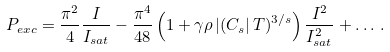Convert formula to latex. <formula><loc_0><loc_0><loc_500><loc_500>P _ { e x c } = \frac { \pi ^ { 2 } } { 4 } \frac { I } { I _ { s a t } } - \frac { \pi ^ { 4 } } { 4 8 } \left ( 1 + \gamma \rho \left | ( C _ { s } \right | T ) ^ { 3 / s } \right ) \frac { I ^ { 2 } } { I _ { s a t } ^ { 2 } } + \dots \, .</formula> 